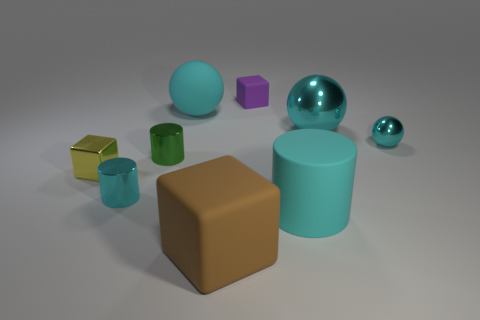Subtract all gray cubes. Subtract all gray balls. How many cubes are left? 3 Add 1 cyan metallic balls. How many objects exist? 10 Subtract all cylinders. How many objects are left? 6 Subtract 1 purple cubes. How many objects are left? 8 Subtract all small purple rubber cylinders. Subtract all blocks. How many objects are left? 6 Add 7 purple objects. How many purple objects are left? 8 Add 4 big cyan objects. How many big cyan objects exist? 7 